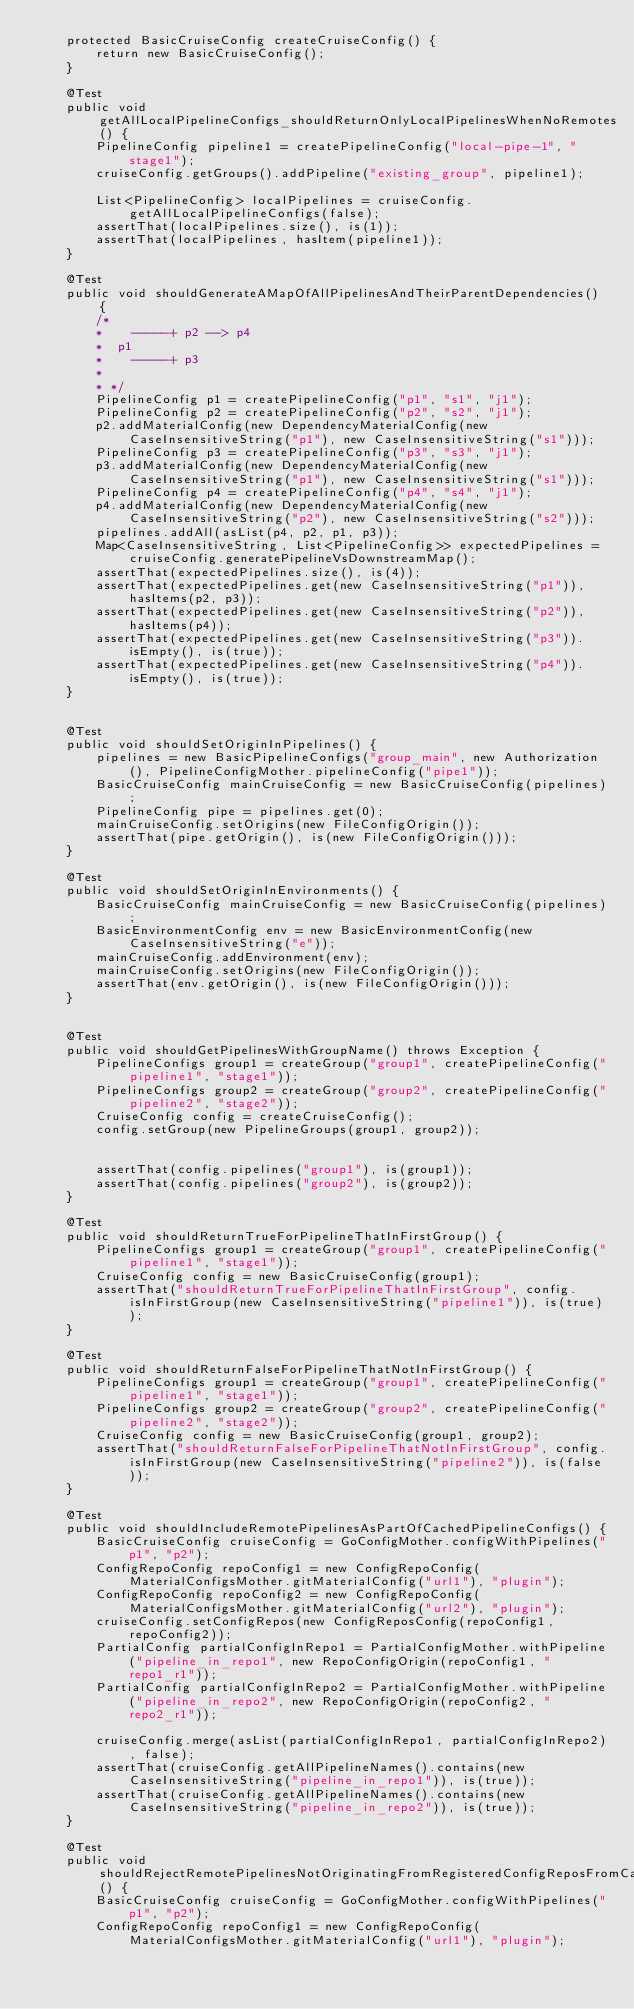Convert code to text. <code><loc_0><loc_0><loc_500><loc_500><_Java_>    protected BasicCruiseConfig createCruiseConfig() {
        return new BasicCruiseConfig();
    }

    @Test
    public void getAllLocalPipelineConfigs_shouldReturnOnlyLocalPipelinesWhenNoRemotes() {
        PipelineConfig pipeline1 = createPipelineConfig("local-pipe-1", "stage1");
        cruiseConfig.getGroups().addPipeline("existing_group", pipeline1);

        List<PipelineConfig> localPipelines = cruiseConfig.getAllLocalPipelineConfigs(false);
        assertThat(localPipelines.size(), is(1));
        assertThat(localPipelines, hasItem(pipeline1));
    }

    @Test
    public void shouldGenerateAMapOfAllPipelinesAndTheirParentDependencies() {
        /*
        *    -----+ p2 --> p4
        *  p1
        *    -----+ p3
        *
        * */
        PipelineConfig p1 = createPipelineConfig("p1", "s1", "j1");
        PipelineConfig p2 = createPipelineConfig("p2", "s2", "j1");
        p2.addMaterialConfig(new DependencyMaterialConfig(new CaseInsensitiveString("p1"), new CaseInsensitiveString("s1")));
        PipelineConfig p3 = createPipelineConfig("p3", "s3", "j1");
        p3.addMaterialConfig(new DependencyMaterialConfig(new CaseInsensitiveString("p1"), new CaseInsensitiveString("s1")));
        PipelineConfig p4 = createPipelineConfig("p4", "s4", "j1");
        p4.addMaterialConfig(new DependencyMaterialConfig(new CaseInsensitiveString("p2"), new CaseInsensitiveString("s2")));
        pipelines.addAll(asList(p4, p2, p1, p3));
        Map<CaseInsensitiveString, List<PipelineConfig>> expectedPipelines = cruiseConfig.generatePipelineVsDownstreamMap();
        assertThat(expectedPipelines.size(), is(4));
        assertThat(expectedPipelines.get(new CaseInsensitiveString("p1")), hasItems(p2, p3));
        assertThat(expectedPipelines.get(new CaseInsensitiveString("p2")), hasItems(p4));
        assertThat(expectedPipelines.get(new CaseInsensitiveString("p3")).isEmpty(), is(true));
        assertThat(expectedPipelines.get(new CaseInsensitiveString("p4")).isEmpty(), is(true));
    }


    @Test
    public void shouldSetOriginInPipelines() {
        pipelines = new BasicPipelineConfigs("group_main", new Authorization(), PipelineConfigMother.pipelineConfig("pipe1"));
        BasicCruiseConfig mainCruiseConfig = new BasicCruiseConfig(pipelines);
        PipelineConfig pipe = pipelines.get(0);
        mainCruiseConfig.setOrigins(new FileConfigOrigin());
        assertThat(pipe.getOrigin(), is(new FileConfigOrigin()));
    }

    @Test
    public void shouldSetOriginInEnvironments() {
        BasicCruiseConfig mainCruiseConfig = new BasicCruiseConfig(pipelines);
        BasicEnvironmentConfig env = new BasicEnvironmentConfig(new CaseInsensitiveString("e"));
        mainCruiseConfig.addEnvironment(env);
        mainCruiseConfig.setOrigins(new FileConfigOrigin());
        assertThat(env.getOrigin(), is(new FileConfigOrigin()));
    }


    @Test
    public void shouldGetPipelinesWithGroupName() throws Exception {
        PipelineConfigs group1 = createGroup("group1", createPipelineConfig("pipeline1", "stage1"));
        PipelineConfigs group2 = createGroup("group2", createPipelineConfig("pipeline2", "stage2"));
        CruiseConfig config = createCruiseConfig();
        config.setGroup(new PipelineGroups(group1, group2));


        assertThat(config.pipelines("group1"), is(group1));
        assertThat(config.pipelines("group2"), is(group2));
    }

    @Test
    public void shouldReturnTrueForPipelineThatInFirstGroup() {
        PipelineConfigs group1 = createGroup("group1", createPipelineConfig("pipeline1", "stage1"));
        CruiseConfig config = new BasicCruiseConfig(group1);
        assertThat("shouldReturnTrueForPipelineThatInFirstGroup", config.isInFirstGroup(new CaseInsensitiveString("pipeline1")), is(true));
    }

    @Test
    public void shouldReturnFalseForPipelineThatNotInFirstGroup() {
        PipelineConfigs group1 = createGroup("group1", createPipelineConfig("pipeline1", "stage1"));
        PipelineConfigs group2 = createGroup("group2", createPipelineConfig("pipeline2", "stage2"));
        CruiseConfig config = new BasicCruiseConfig(group1, group2);
        assertThat("shouldReturnFalseForPipelineThatNotInFirstGroup", config.isInFirstGroup(new CaseInsensitiveString("pipeline2")), is(false));
    }

    @Test
    public void shouldIncludeRemotePipelinesAsPartOfCachedPipelineConfigs() {
        BasicCruiseConfig cruiseConfig = GoConfigMother.configWithPipelines("p1", "p2");
        ConfigRepoConfig repoConfig1 = new ConfigRepoConfig(MaterialConfigsMother.gitMaterialConfig("url1"), "plugin");
        ConfigRepoConfig repoConfig2 = new ConfigRepoConfig(MaterialConfigsMother.gitMaterialConfig("url2"), "plugin");
        cruiseConfig.setConfigRepos(new ConfigReposConfig(repoConfig1, repoConfig2));
        PartialConfig partialConfigInRepo1 = PartialConfigMother.withPipeline("pipeline_in_repo1", new RepoConfigOrigin(repoConfig1, "repo1_r1"));
        PartialConfig partialConfigInRepo2 = PartialConfigMother.withPipeline("pipeline_in_repo2", new RepoConfigOrigin(repoConfig2, "repo2_r1"));

        cruiseConfig.merge(asList(partialConfigInRepo1, partialConfigInRepo2), false);
        assertThat(cruiseConfig.getAllPipelineNames().contains(new CaseInsensitiveString("pipeline_in_repo1")), is(true));
        assertThat(cruiseConfig.getAllPipelineNames().contains(new CaseInsensitiveString("pipeline_in_repo2")), is(true));
    }

    @Test
    public void shouldRejectRemotePipelinesNotOriginatingFromRegisteredConfigReposFromCachedPipelineConfigs() {
        BasicCruiseConfig cruiseConfig = GoConfigMother.configWithPipelines("p1", "p2");
        ConfigRepoConfig repoConfig1 = new ConfigRepoConfig(MaterialConfigsMother.gitMaterialConfig("url1"), "plugin");</code> 